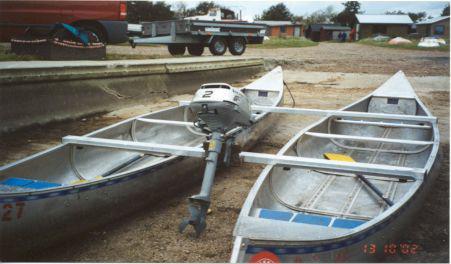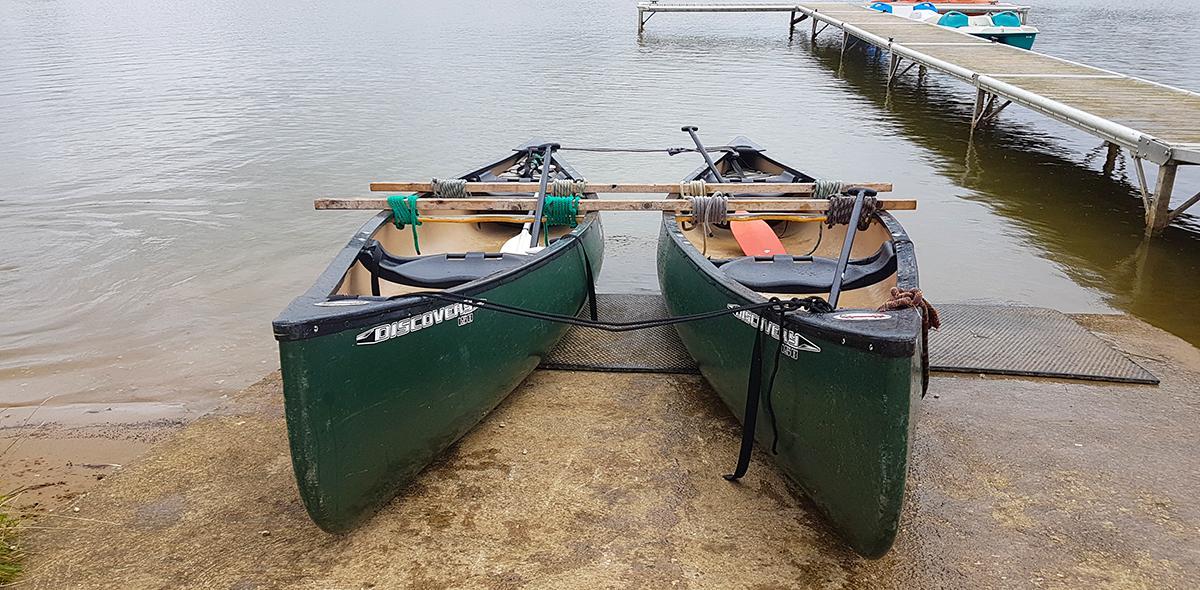The first image is the image on the left, the second image is the image on the right. Considering the images on both sides, is "There is three humans in the right image." valid? Answer yes or no. No. The first image is the image on the left, the second image is the image on the right. Given the left and right images, does the statement "There is at least one human standing inside a boat while the boat is in the water." hold true? Answer yes or no. No. The first image is the image on the left, the second image is the image on the right. Given the left and right images, does the statement "In one image, two green canoes are side by side" hold true? Answer yes or no. Yes. The first image is the image on the left, the second image is the image on the right. For the images displayed, is the sentence "In one picture the canoes are in the water and in the other picture the canoes are not in the water." factually correct? Answer yes or no. No. 